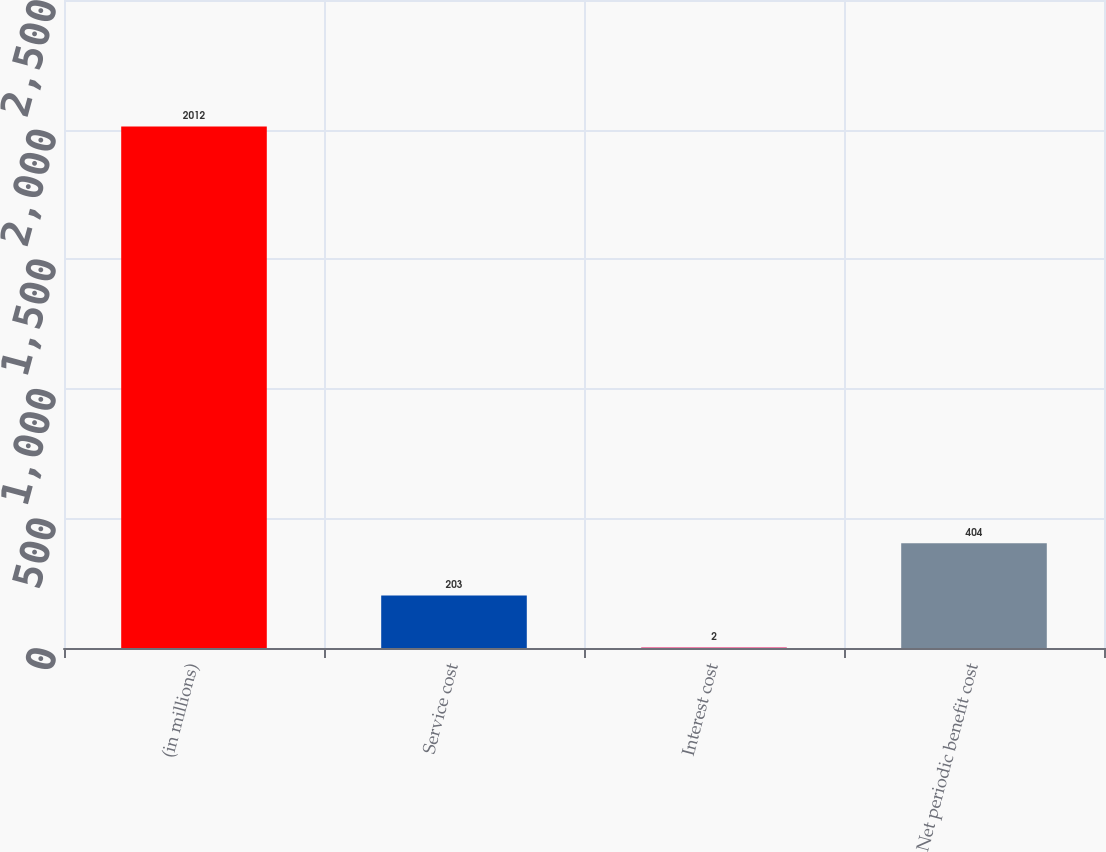Convert chart to OTSL. <chart><loc_0><loc_0><loc_500><loc_500><bar_chart><fcel>(in millions)<fcel>Service cost<fcel>Interest cost<fcel>Net periodic benefit cost<nl><fcel>2012<fcel>203<fcel>2<fcel>404<nl></chart> 